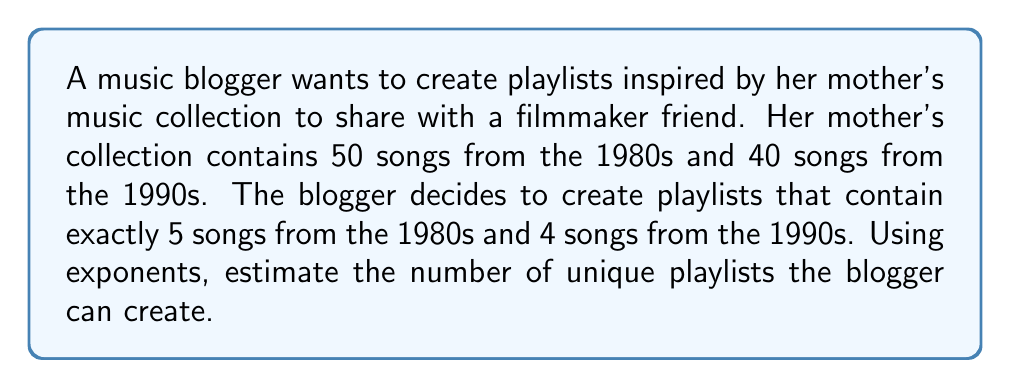Help me with this question. To solve this problem, we'll use the combination formula and the multiplication principle of counting.

1. For the 1980s songs:
   - We need to choose 5 songs out of 50
   - This can be represented as $\binom{50}{5}$
   - We can estimate this using the formula: $\binom{n}{k} \approx \frac{n^k}{k!}$
   - So, $\binom{50}{5} \approx \frac{50^5}{5!}$

2. For the 1990s songs:
   - We need to choose 4 songs out of 40
   - This can be represented as $\binom{40}{4}$
   - Using the same estimation: $\binom{40}{4} \approx \frac{40^4}{4!}$

3. By the multiplication principle, the total number of possible playlists is:
   $$\text{Total playlists} \approx \frac{50^5}{5!} \cdot \frac{40^4}{4!}$$

4. Let's calculate:
   $$\begin{align*}
   \text{Total playlists} &\approx \frac{50^5}{5!} \cdot \frac{40^4}{4!} \\
   &= \frac{3,125,000,000}{120} \cdot \frac{2,560,000}{24} \\
   &= 26,041,666 \cdot 106,666 \\
   &\approx 2.78 \times 10^{12}
   \end{align*}$$

Therefore, the blogger can create approximately $2.78 \times 10^{12}$ unique playlists.
Answer: $2.78 \times 10^{12}$ unique playlists 